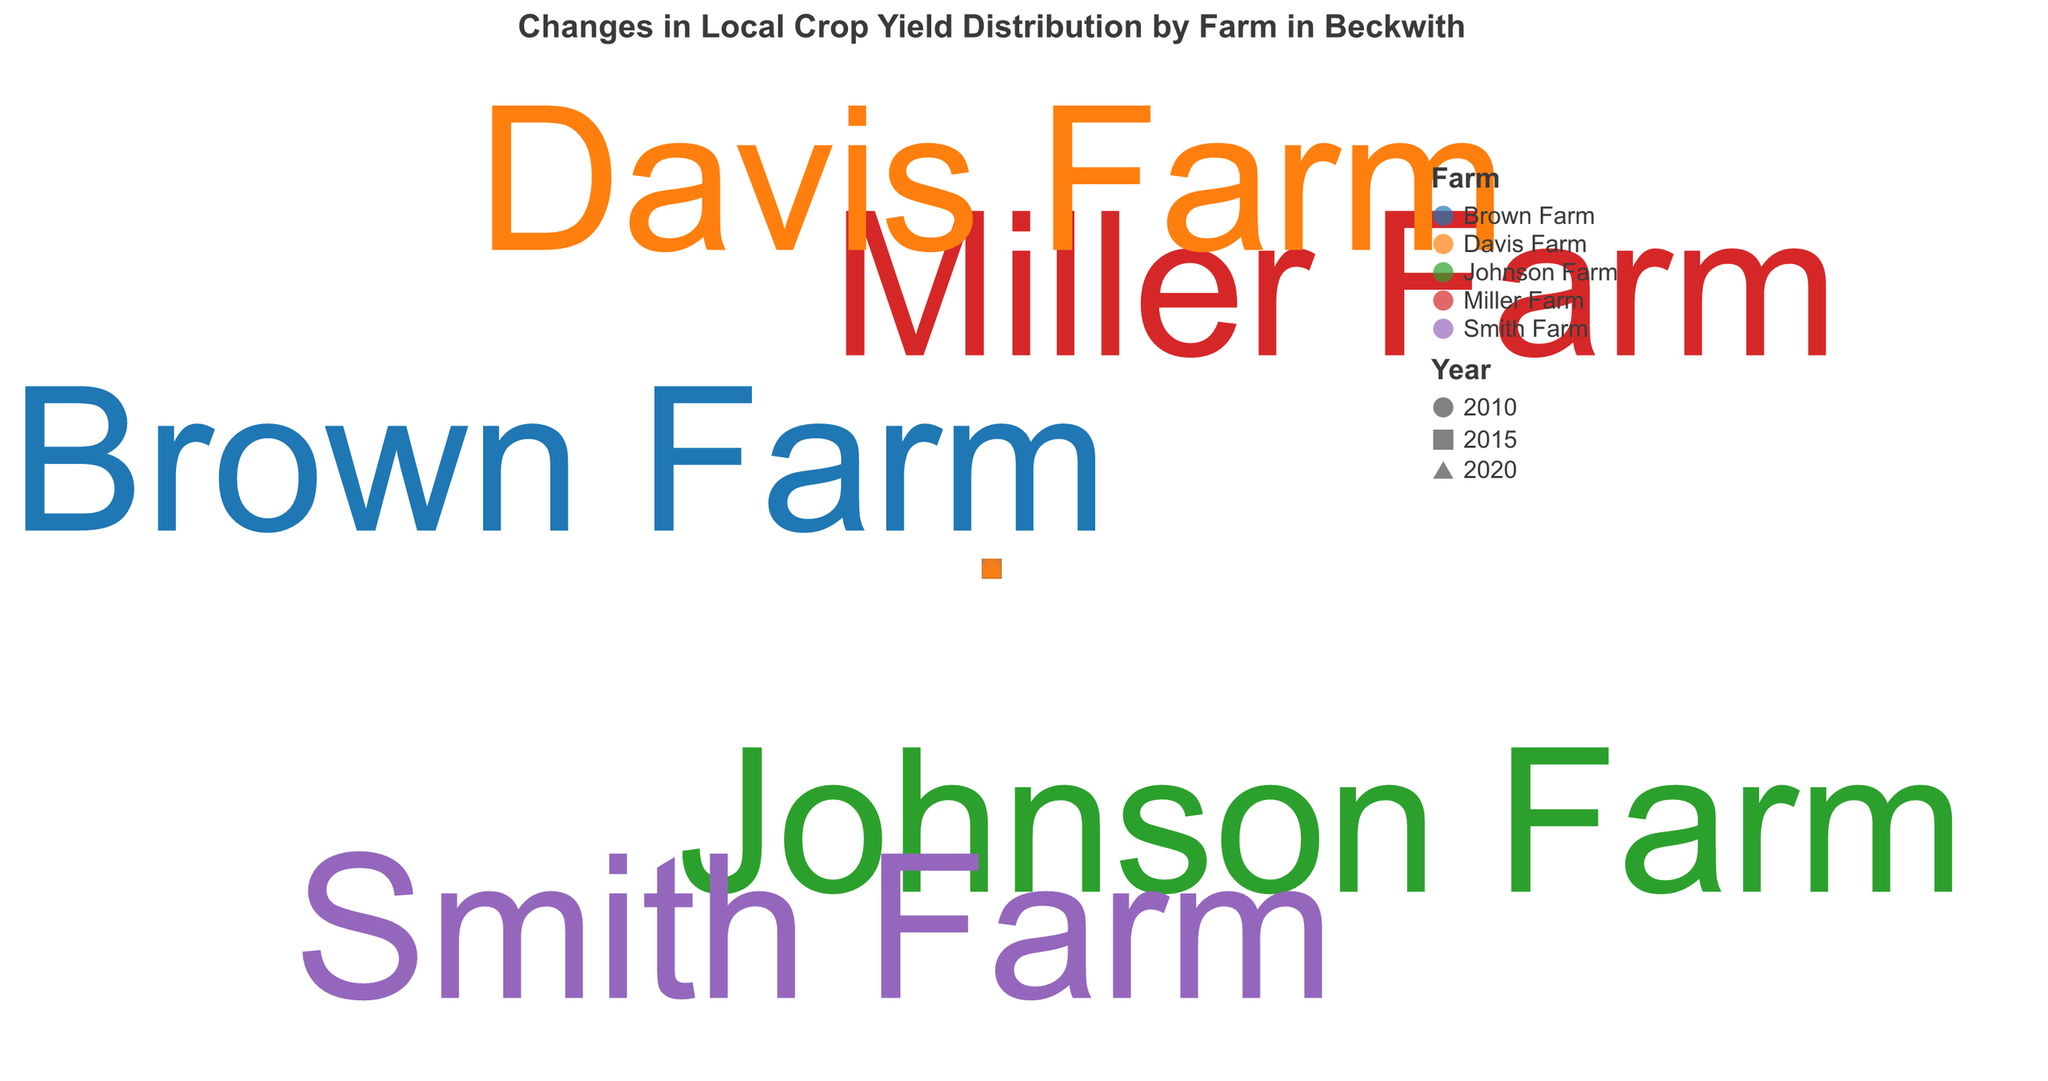How many farms are represented in the chart? By counting the distinct farm names, we see there are five different farms: Miller Farm, Johnson Farm, Smith Farm, Brown Farm, and Davis Farm.
Answer: Five Which farm shows the greatest increase in crop yield from 2010 to 2020? Comparing the yields for each farm across the years, Miller Farm increases from 80 to 90, Johnson Farm from 75 to 82, Smith Farm from 70 to 77, Brown Farm from 85 to 92, and Davis Farm from 60 to 65. The biggest increase is at Brown Farm, increasing by 7.
Answer: Brown Farm What is the average yield of Smith Farm across all years? The yields for Smith Farm are 70 (2010), 73 (2015), and 77 (2020). The average yield is calculated as (70 + 73 + 77) / 3 = 220 / 3 ≈ 73.3.
Answer: ~73.3 How does the crop yield of Davis Farm in 2020 compare to that in 2010? The crop yield of Davis Farm in 2020 is 65, while in 2010 it is 60.
Answer: Greater Which farm had the lowest yield in 2010, and what was this yield? By comparing all farms' yields in 2010, Davis Farm yielded the lowest at 60.
Answer: Davis Farm, 60 Identify the trend of crop yields for Miller Farm from 2010 to 2020. The yields for Miller Farm show an increasing trend: 80 (2010), 85 (2015), and 90 (2020).
Answer: Increasing Is the crop yield distribution of Brown Farm higher or lower than Johnson Farm in 2015? In 2015, Brown Farm has a yield of 88, whereas Johnson Farm has 78.
Answer: Higher What is unique about the farm labels on the chart? The farm labels appear only for the year 2020, providing a contextual guide for the latest data points.
Answer: Shown for 2020 only Which farm displayed the smallest change in yield from 2015 to 2020? Calculating the difference between 2015 and 2020 yields: Miller Farm (5), Johnson Farm (4), Smith Farm (4), Brown Farm (4), and Davis Farm (3). The smallest change is at Davis Farm with an increase of 3.
Answer: Davis Farm How are different years represented in the chart? Different years (2010, 2015, and 2020) are represented by distinct shapes for each data point: circle for 2010, square for 2015, and triangle-up for 2020.
Answer: Different shapes 